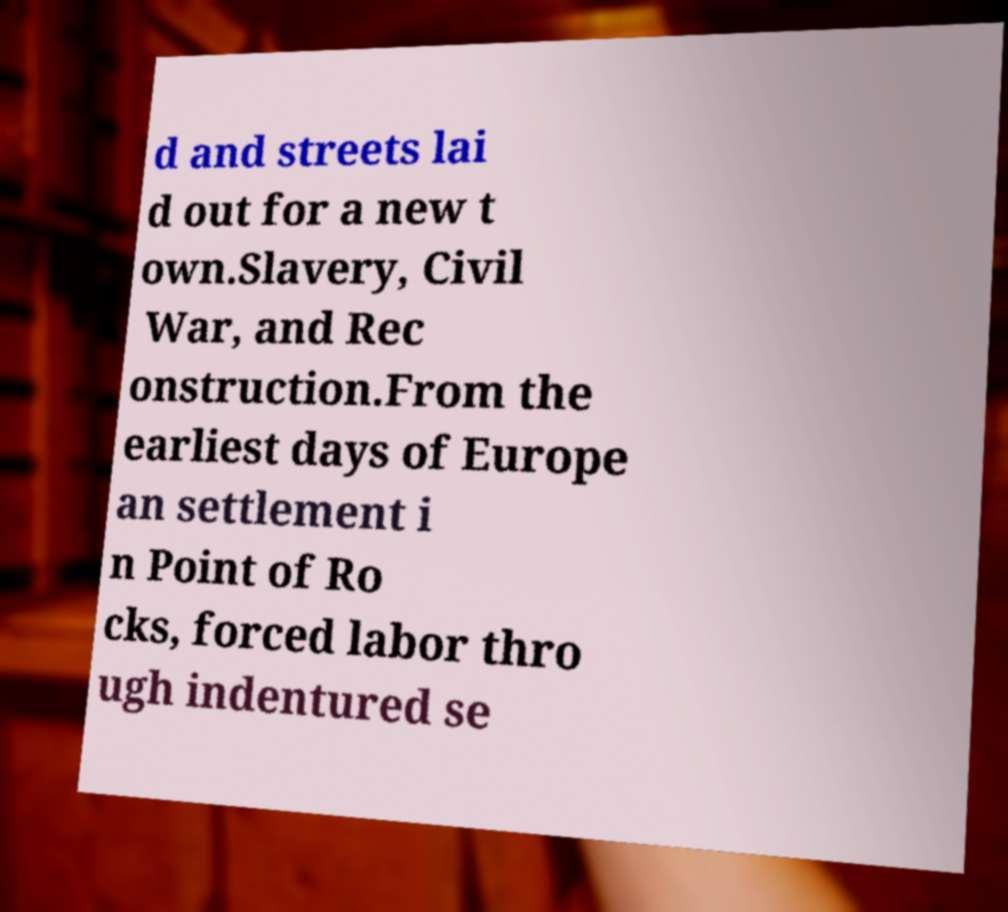Could you assist in decoding the text presented in this image and type it out clearly? d and streets lai d out for a new t own.Slavery, Civil War, and Rec onstruction.From the earliest days of Europe an settlement i n Point of Ro cks, forced labor thro ugh indentured se 